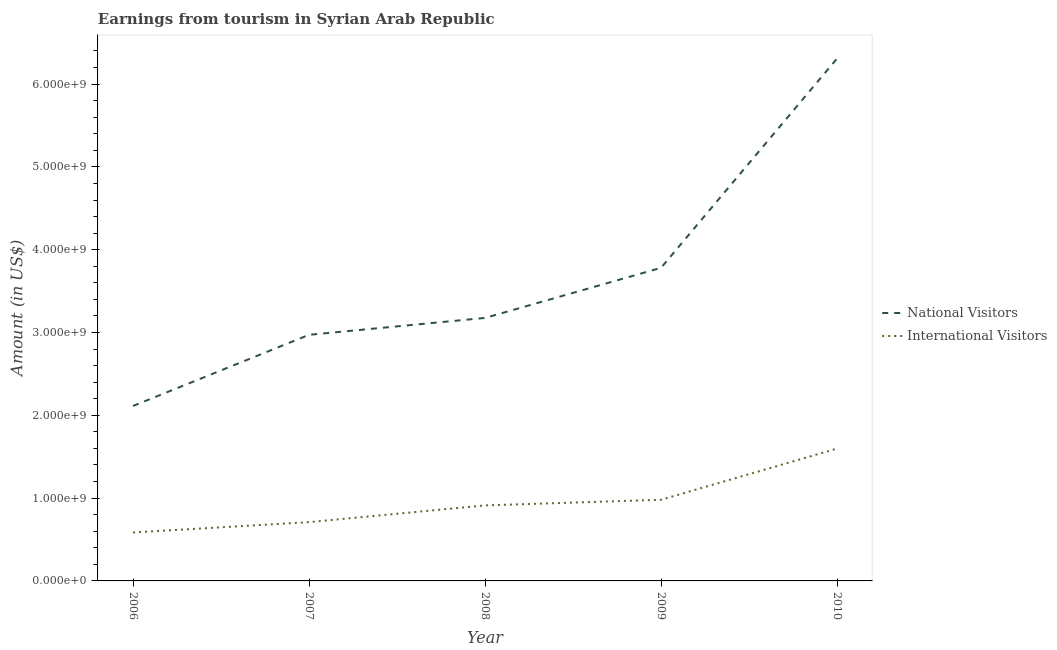Does the line corresponding to amount earned from national visitors intersect with the line corresponding to amount earned from international visitors?
Your response must be concise. No. What is the amount earned from international visitors in 2010?
Keep it short and to the point. 1.60e+09. Across all years, what is the maximum amount earned from international visitors?
Provide a succinct answer. 1.60e+09. Across all years, what is the minimum amount earned from national visitors?
Ensure brevity in your answer.  2.11e+09. In which year was the amount earned from national visitors minimum?
Your response must be concise. 2006. What is the total amount earned from international visitors in the graph?
Provide a succinct answer. 4.78e+09. What is the difference between the amount earned from national visitors in 2006 and that in 2010?
Your response must be concise. -4.20e+09. What is the difference between the amount earned from national visitors in 2007 and the amount earned from international visitors in 2009?
Make the answer very short. 1.99e+09. What is the average amount earned from national visitors per year?
Ensure brevity in your answer.  3.67e+09. In the year 2006, what is the difference between the amount earned from international visitors and amount earned from national visitors?
Give a very brief answer. -1.53e+09. What is the ratio of the amount earned from international visitors in 2009 to that in 2010?
Your response must be concise. 0.61. Is the difference between the amount earned from national visitors in 2007 and 2010 greater than the difference between the amount earned from international visitors in 2007 and 2010?
Provide a short and direct response. No. What is the difference between the highest and the second highest amount earned from national visitors?
Your response must be concise. 2.53e+09. What is the difference between the highest and the lowest amount earned from international visitors?
Keep it short and to the point. 1.01e+09. In how many years, is the amount earned from national visitors greater than the average amount earned from national visitors taken over all years?
Ensure brevity in your answer.  2. Is the amount earned from national visitors strictly greater than the amount earned from international visitors over the years?
Give a very brief answer. Yes. How many lines are there?
Keep it short and to the point. 2. How many years are there in the graph?
Ensure brevity in your answer.  5. Where does the legend appear in the graph?
Provide a succinct answer. Center right. What is the title of the graph?
Make the answer very short. Earnings from tourism in Syrian Arab Republic. Does "% of GNI" appear as one of the legend labels in the graph?
Your response must be concise. No. What is the label or title of the X-axis?
Provide a succinct answer. Year. What is the label or title of the Y-axis?
Make the answer very short. Amount (in US$). What is the Amount (in US$) of National Visitors in 2006?
Your answer should be very brief. 2.11e+09. What is the Amount (in US$) in International Visitors in 2006?
Your answer should be very brief. 5.85e+08. What is the Amount (in US$) in National Visitors in 2007?
Give a very brief answer. 2.97e+09. What is the Amount (in US$) of International Visitors in 2007?
Your answer should be compact. 7.10e+08. What is the Amount (in US$) in National Visitors in 2008?
Ensure brevity in your answer.  3.18e+09. What is the Amount (in US$) in International Visitors in 2008?
Ensure brevity in your answer.  9.12e+08. What is the Amount (in US$) in National Visitors in 2009?
Provide a short and direct response. 3.78e+09. What is the Amount (in US$) in International Visitors in 2009?
Provide a short and direct response. 9.80e+08. What is the Amount (in US$) in National Visitors in 2010?
Offer a terse response. 6.31e+09. What is the Amount (in US$) in International Visitors in 2010?
Provide a succinct answer. 1.60e+09. Across all years, what is the maximum Amount (in US$) in National Visitors?
Provide a succinct answer. 6.31e+09. Across all years, what is the maximum Amount (in US$) of International Visitors?
Keep it short and to the point. 1.60e+09. Across all years, what is the minimum Amount (in US$) of National Visitors?
Make the answer very short. 2.11e+09. Across all years, what is the minimum Amount (in US$) in International Visitors?
Make the answer very short. 5.85e+08. What is the total Amount (in US$) in National Visitors in the graph?
Your response must be concise. 1.84e+1. What is the total Amount (in US$) of International Visitors in the graph?
Provide a short and direct response. 4.78e+09. What is the difference between the Amount (in US$) of National Visitors in 2006 and that in 2007?
Ensure brevity in your answer.  -8.59e+08. What is the difference between the Amount (in US$) in International Visitors in 2006 and that in 2007?
Keep it short and to the point. -1.25e+08. What is the difference between the Amount (in US$) of National Visitors in 2006 and that in 2008?
Make the answer very short. -1.06e+09. What is the difference between the Amount (in US$) of International Visitors in 2006 and that in 2008?
Your response must be concise. -3.27e+08. What is the difference between the Amount (in US$) in National Visitors in 2006 and that in 2009?
Ensure brevity in your answer.  -1.67e+09. What is the difference between the Amount (in US$) of International Visitors in 2006 and that in 2009?
Give a very brief answer. -3.95e+08. What is the difference between the Amount (in US$) in National Visitors in 2006 and that in 2010?
Ensure brevity in your answer.  -4.20e+09. What is the difference between the Amount (in US$) in International Visitors in 2006 and that in 2010?
Give a very brief answer. -1.01e+09. What is the difference between the Amount (in US$) of National Visitors in 2007 and that in 2008?
Offer a very short reply. -2.04e+08. What is the difference between the Amount (in US$) in International Visitors in 2007 and that in 2008?
Your answer should be very brief. -2.02e+08. What is the difference between the Amount (in US$) of National Visitors in 2007 and that in 2009?
Your answer should be compact. -8.09e+08. What is the difference between the Amount (in US$) of International Visitors in 2007 and that in 2009?
Your answer should be compact. -2.70e+08. What is the difference between the Amount (in US$) of National Visitors in 2007 and that in 2010?
Offer a terse response. -3.34e+09. What is the difference between the Amount (in US$) in International Visitors in 2007 and that in 2010?
Your answer should be compact. -8.88e+08. What is the difference between the Amount (in US$) in National Visitors in 2008 and that in 2009?
Provide a short and direct response. -6.05e+08. What is the difference between the Amount (in US$) of International Visitors in 2008 and that in 2009?
Keep it short and to the point. -6.80e+07. What is the difference between the Amount (in US$) of National Visitors in 2008 and that in 2010?
Your answer should be very brief. -3.13e+09. What is the difference between the Amount (in US$) of International Visitors in 2008 and that in 2010?
Your response must be concise. -6.86e+08. What is the difference between the Amount (in US$) of National Visitors in 2009 and that in 2010?
Keep it short and to the point. -2.53e+09. What is the difference between the Amount (in US$) in International Visitors in 2009 and that in 2010?
Ensure brevity in your answer.  -6.18e+08. What is the difference between the Amount (in US$) of National Visitors in 2006 and the Amount (in US$) of International Visitors in 2007?
Offer a terse response. 1.40e+09. What is the difference between the Amount (in US$) of National Visitors in 2006 and the Amount (in US$) of International Visitors in 2008?
Make the answer very short. 1.20e+09. What is the difference between the Amount (in US$) of National Visitors in 2006 and the Amount (in US$) of International Visitors in 2009?
Your answer should be very brief. 1.13e+09. What is the difference between the Amount (in US$) of National Visitors in 2006 and the Amount (in US$) of International Visitors in 2010?
Your answer should be very brief. 5.15e+08. What is the difference between the Amount (in US$) of National Visitors in 2007 and the Amount (in US$) of International Visitors in 2008?
Offer a terse response. 2.06e+09. What is the difference between the Amount (in US$) in National Visitors in 2007 and the Amount (in US$) in International Visitors in 2009?
Your answer should be compact. 1.99e+09. What is the difference between the Amount (in US$) in National Visitors in 2007 and the Amount (in US$) in International Visitors in 2010?
Give a very brief answer. 1.37e+09. What is the difference between the Amount (in US$) in National Visitors in 2008 and the Amount (in US$) in International Visitors in 2009?
Give a very brief answer. 2.20e+09. What is the difference between the Amount (in US$) of National Visitors in 2008 and the Amount (in US$) of International Visitors in 2010?
Your answer should be compact. 1.58e+09. What is the difference between the Amount (in US$) in National Visitors in 2009 and the Amount (in US$) in International Visitors in 2010?
Your answer should be very brief. 2.18e+09. What is the average Amount (in US$) of National Visitors per year?
Offer a terse response. 3.67e+09. What is the average Amount (in US$) of International Visitors per year?
Your answer should be very brief. 9.57e+08. In the year 2006, what is the difference between the Amount (in US$) of National Visitors and Amount (in US$) of International Visitors?
Offer a terse response. 1.53e+09. In the year 2007, what is the difference between the Amount (in US$) of National Visitors and Amount (in US$) of International Visitors?
Your answer should be very brief. 2.26e+09. In the year 2008, what is the difference between the Amount (in US$) in National Visitors and Amount (in US$) in International Visitors?
Make the answer very short. 2.26e+09. In the year 2009, what is the difference between the Amount (in US$) of National Visitors and Amount (in US$) of International Visitors?
Your answer should be very brief. 2.80e+09. In the year 2010, what is the difference between the Amount (in US$) in National Visitors and Amount (in US$) in International Visitors?
Your response must be concise. 4.71e+09. What is the ratio of the Amount (in US$) of National Visitors in 2006 to that in 2007?
Give a very brief answer. 0.71. What is the ratio of the Amount (in US$) in International Visitors in 2006 to that in 2007?
Your response must be concise. 0.82. What is the ratio of the Amount (in US$) in National Visitors in 2006 to that in 2008?
Your answer should be very brief. 0.67. What is the ratio of the Amount (in US$) in International Visitors in 2006 to that in 2008?
Provide a short and direct response. 0.64. What is the ratio of the Amount (in US$) of National Visitors in 2006 to that in 2009?
Provide a short and direct response. 0.56. What is the ratio of the Amount (in US$) in International Visitors in 2006 to that in 2009?
Offer a very short reply. 0.6. What is the ratio of the Amount (in US$) of National Visitors in 2006 to that in 2010?
Your answer should be compact. 0.34. What is the ratio of the Amount (in US$) in International Visitors in 2006 to that in 2010?
Give a very brief answer. 0.37. What is the ratio of the Amount (in US$) of National Visitors in 2007 to that in 2008?
Provide a short and direct response. 0.94. What is the ratio of the Amount (in US$) in International Visitors in 2007 to that in 2008?
Keep it short and to the point. 0.78. What is the ratio of the Amount (in US$) in National Visitors in 2007 to that in 2009?
Make the answer very short. 0.79. What is the ratio of the Amount (in US$) of International Visitors in 2007 to that in 2009?
Ensure brevity in your answer.  0.72. What is the ratio of the Amount (in US$) of National Visitors in 2007 to that in 2010?
Offer a very short reply. 0.47. What is the ratio of the Amount (in US$) of International Visitors in 2007 to that in 2010?
Provide a succinct answer. 0.44. What is the ratio of the Amount (in US$) of National Visitors in 2008 to that in 2009?
Provide a short and direct response. 0.84. What is the ratio of the Amount (in US$) of International Visitors in 2008 to that in 2009?
Keep it short and to the point. 0.93. What is the ratio of the Amount (in US$) in National Visitors in 2008 to that in 2010?
Keep it short and to the point. 0.5. What is the ratio of the Amount (in US$) in International Visitors in 2008 to that in 2010?
Provide a succinct answer. 0.57. What is the ratio of the Amount (in US$) in National Visitors in 2009 to that in 2010?
Provide a succinct answer. 0.6. What is the ratio of the Amount (in US$) in International Visitors in 2009 to that in 2010?
Give a very brief answer. 0.61. What is the difference between the highest and the second highest Amount (in US$) of National Visitors?
Your answer should be compact. 2.53e+09. What is the difference between the highest and the second highest Amount (in US$) in International Visitors?
Ensure brevity in your answer.  6.18e+08. What is the difference between the highest and the lowest Amount (in US$) in National Visitors?
Your response must be concise. 4.20e+09. What is the difference between the highest and the lowest Amount (in US$) in International Visitors?
Your answer should be compact. 1.01e+09. 